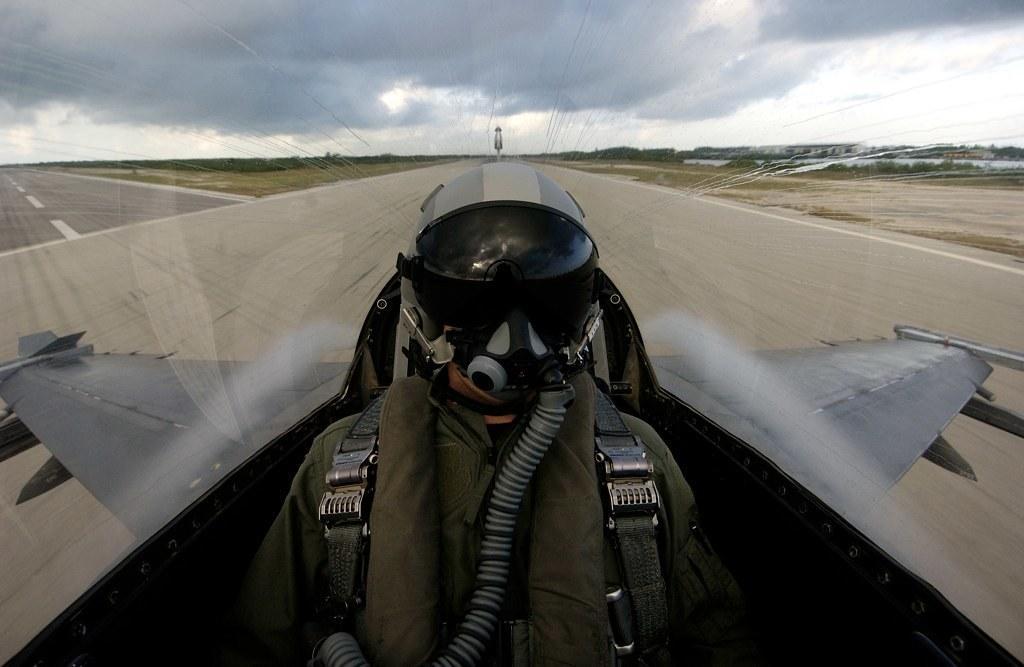Describe this image in one or two sentences. There is a person inside airplane and wore helmet and we can see airplane wings. On the background we can see road and sky with clouds. 